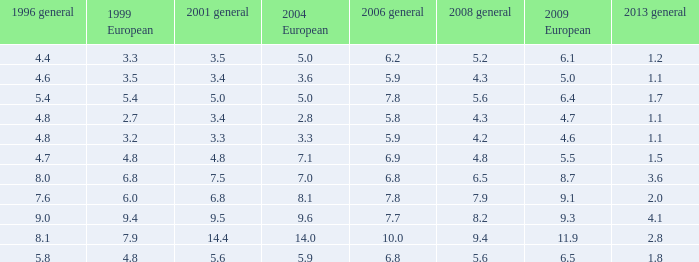Considering european 2009 is lower None. 